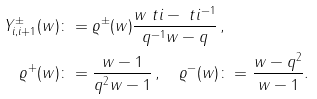Convert formula to latex. <formula><loc_0><loc_0><loc_500><loc_500>Y ^ { \pm } _ { i , i + 1 } ( w ) & \colon = \varrho ^ { \pm } ( w ) \frac { w \ t i - \ t i ^ { - 1 } } { q ^ { - 1 } w - q } \, , \\ \varrho ^ { + } ( w ) & \colon = \frac { w - 1 } { q ^ { 2 } w - 1 } \, , \quad \varrho ^ { - } ( w ) \colon = \frac { w - q ^ { 2 } } { w - 1 } .</formula> 